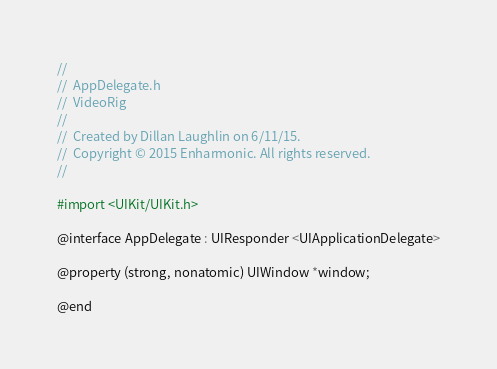Convert code to text. <code><loc_0><loc_0><loc_500><loc_500><_C_>//
//  AppDelegate.h
//  VideoRig
//
//  Created by Dillan Laughlin on 6/11/15.
//  Copyright © 2015 Enharmonic. All rights reserved.
//

#import <UIKit/UIKit.h>

@interface AppDelegate : UIResponder <UIApplicationDelegate>

@property (strong, nonatomic) UIWindow *window;

@end

</code> 